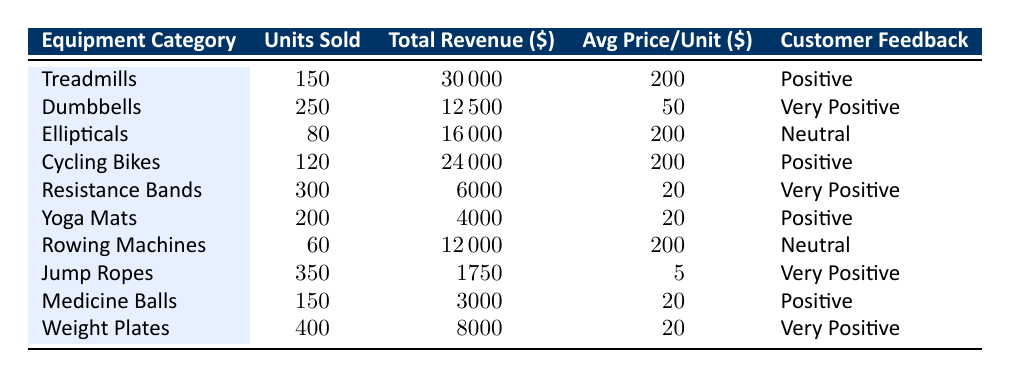What is the total revenue from Resistance Bands? The total revenue for Resistance Bands is directly provided in the table. According to the table, the total revenue for Resistance Bands is 6000.
Answer: 6000 How many units of Weight Plates were sold? The number of units sold for Weight Plates is listed in the table. It shows that 400 units of Weight Plates were sold.
Answer: 400 Which equipment category had the highest units sold? By inspecting the units sold for each category in the table, we see that Jump Ropes had the highest units sold at 350.
Answer: Jump Ropes What is the average price per unit for Dumbbells? The average price per unit for Dumbbells is 50, as stated in the table under the corresponding category.
Answer: 50 How does the total revenue of Treadmills compare to that of Cycling Bikes? The total revenue for Treadmills is 30000, and for Cycling Bikes, it is 24000. Since 30000 is greater than 24000, Treadmills have higher revenue than Cycling Bikes.
Answer: Treadmills has higher total revenue What is the total revenue generated by equipment categories with "Very Positive" feedback? We sum up the total revenue for categories with "Very Positive" feedback: Dumbbells (12500) + Resistance Bands (6000) + Jump Ropes (1750) + Weight Plates (8000) = 30000.
Answer: 30000 Is the average price per unit for Ellipticals and Treadmills the same? The average price per unit for Ellipticals is 200, and for Treadmills, it is also 200; thus, they are the same.
Answer: Yes Which equipment category had the lowest total revenue? Reviewing the total revenue values across categories, Jump Ropes had the lowest total revenue at 1750.
Answer: Jump Ropes What is the median of units sold across all equipment categories? To find the median, we first list the units sold: 60, 80, 150, 150, 120, 200, 250, 300, 350, 400. The median is the average of the 5th and 6th values (150 and 200), which is (150 + 200) / 2 = 175.
Answer: 175 